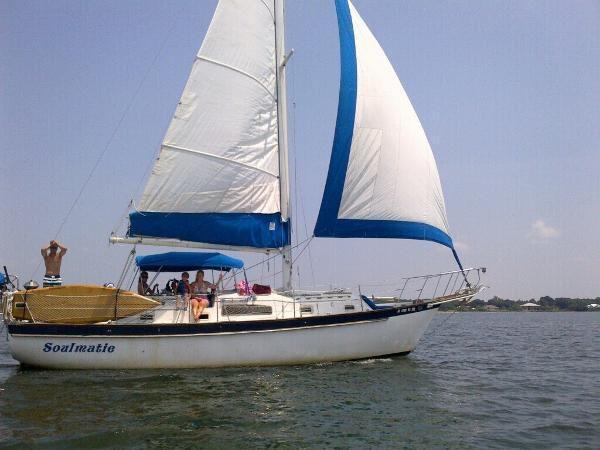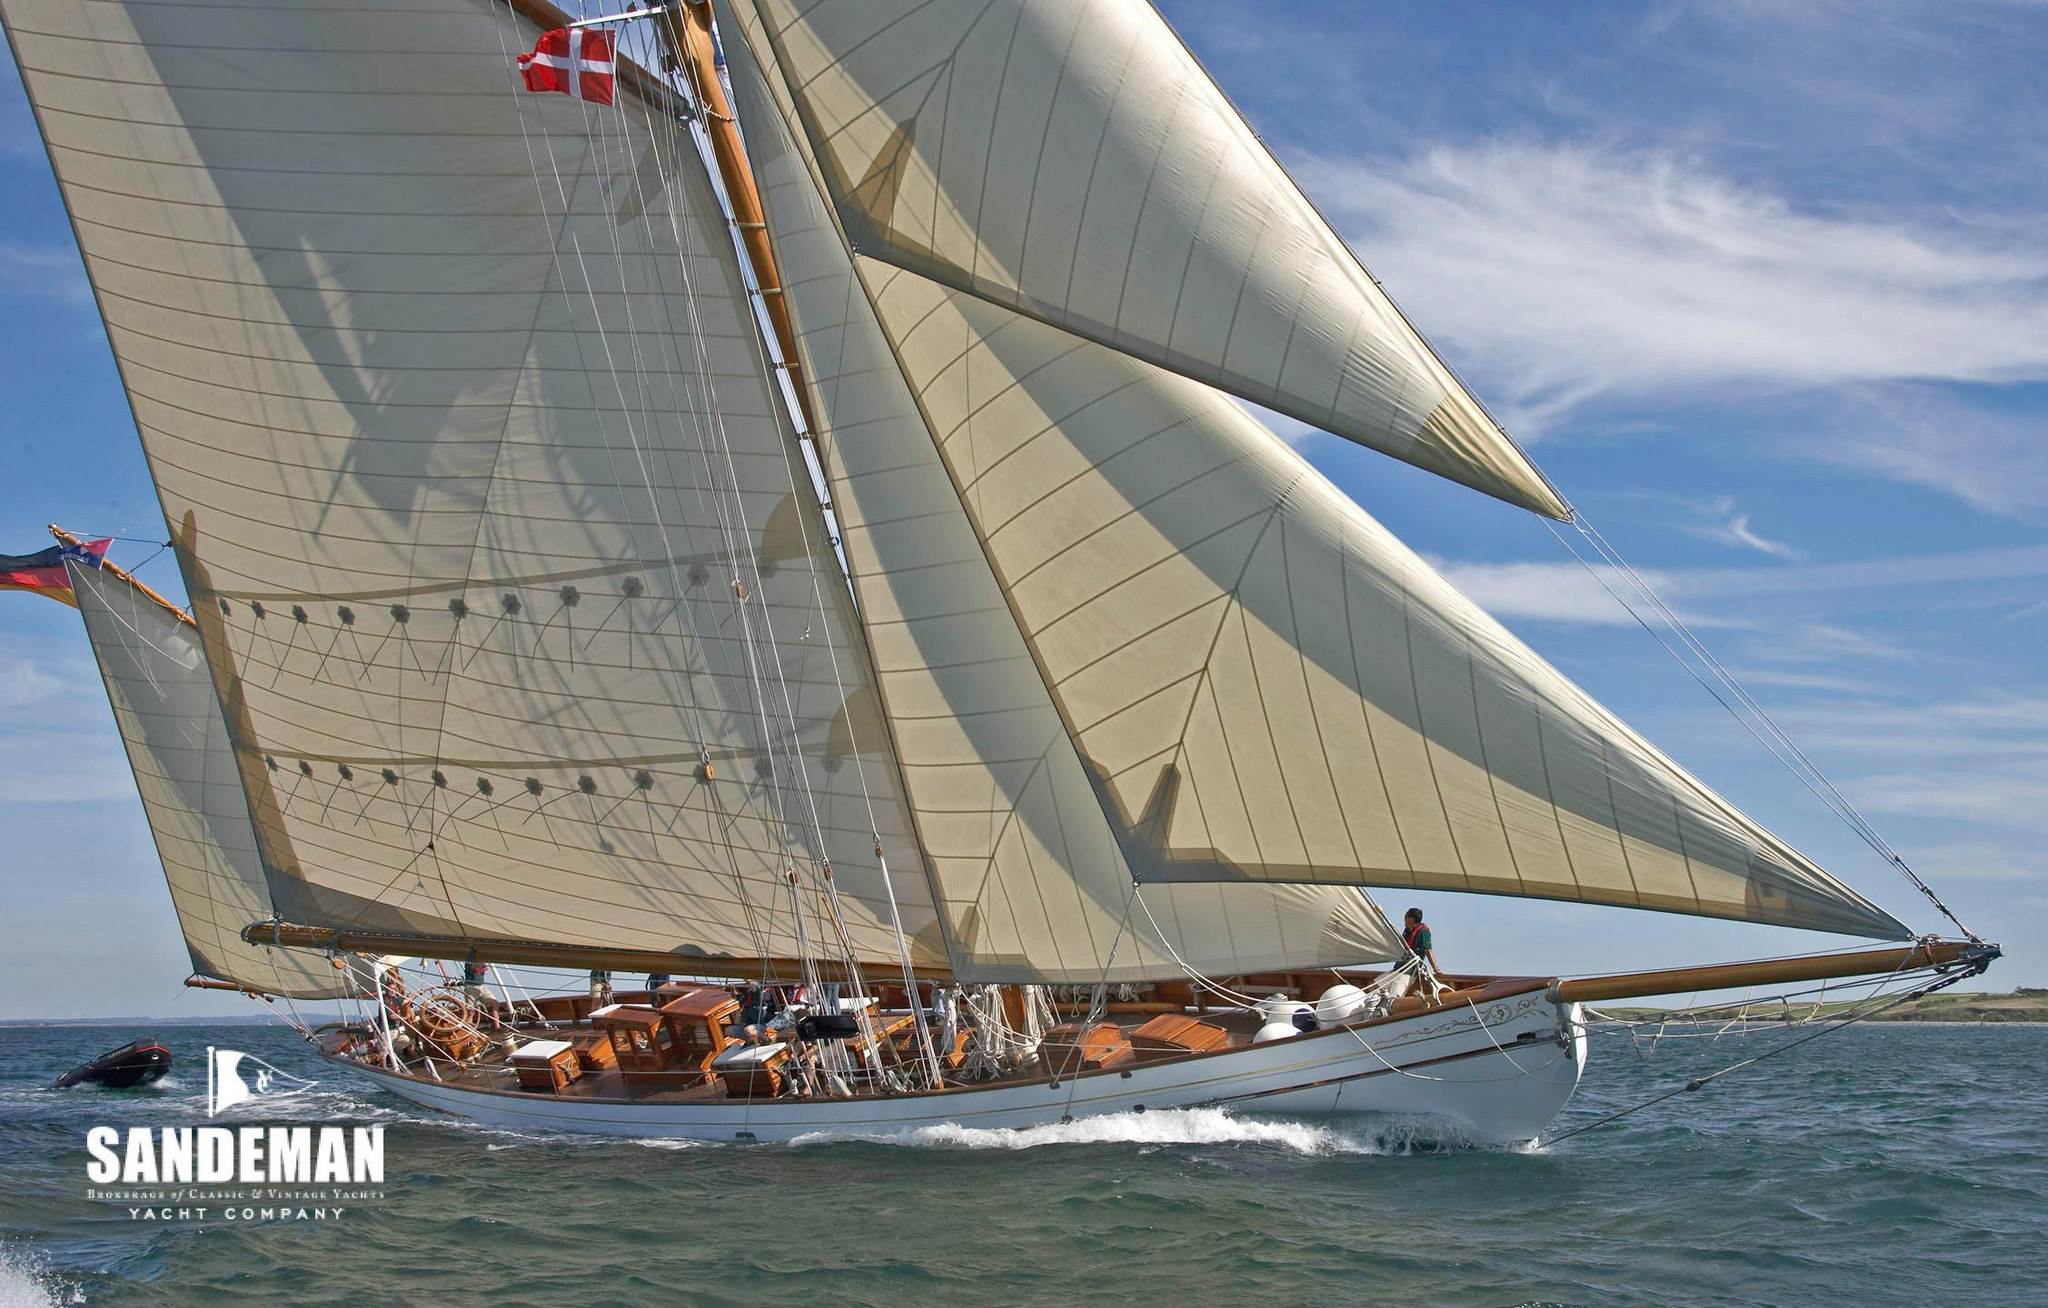The first image is the image on the left, the second image is the image on the right. Given the left and right images, does the statement "The left and right image contains the same number of sailboats facing right." hold true? Answer yes or no. Yes. The first image is the image on the left, the second image is the image on the right. Evaluate the accuracy of this statement regarding the images: "The left image shows a rightward-facing boat with a colored border on its leading unfurled sail and at least one colored canopy.". Is it true? Answer yes or no. Yes. 